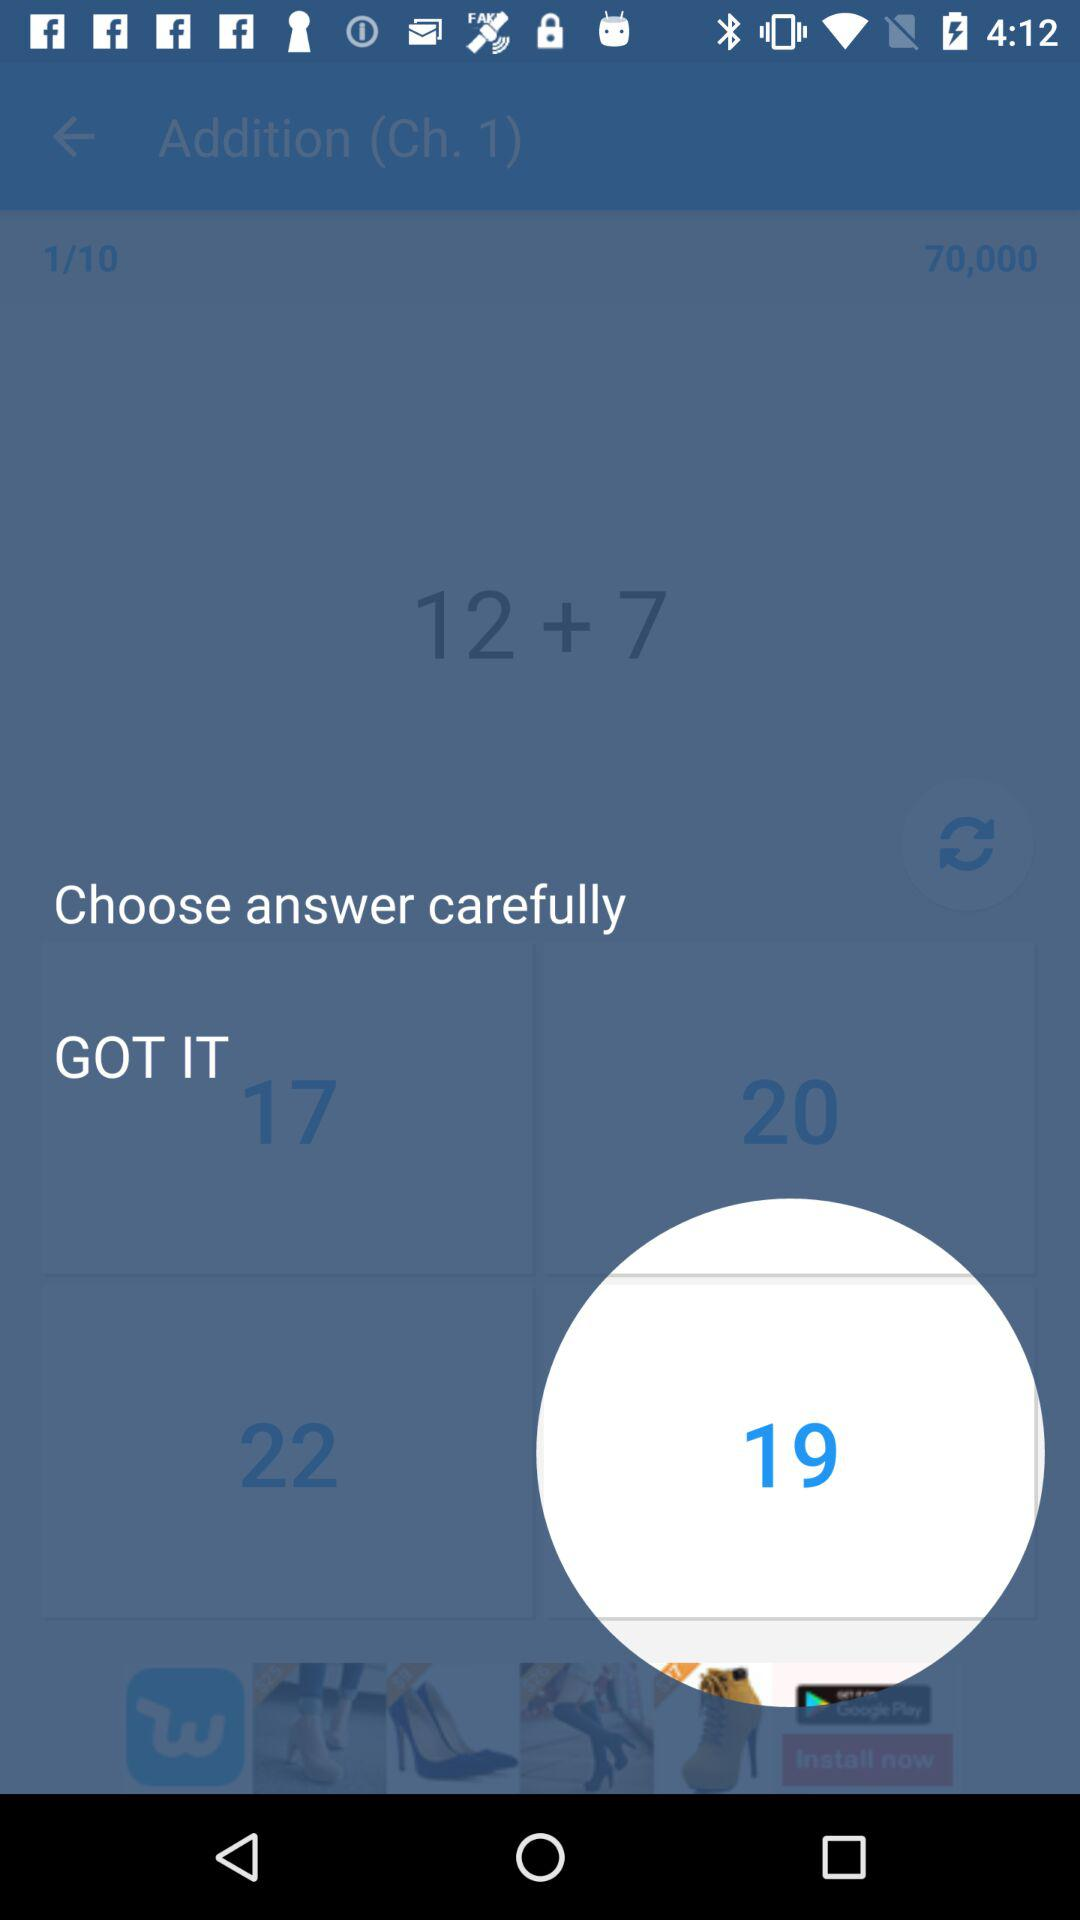What is the difference between 22 and 17?
Answer the question using a single word or phrase. 5 